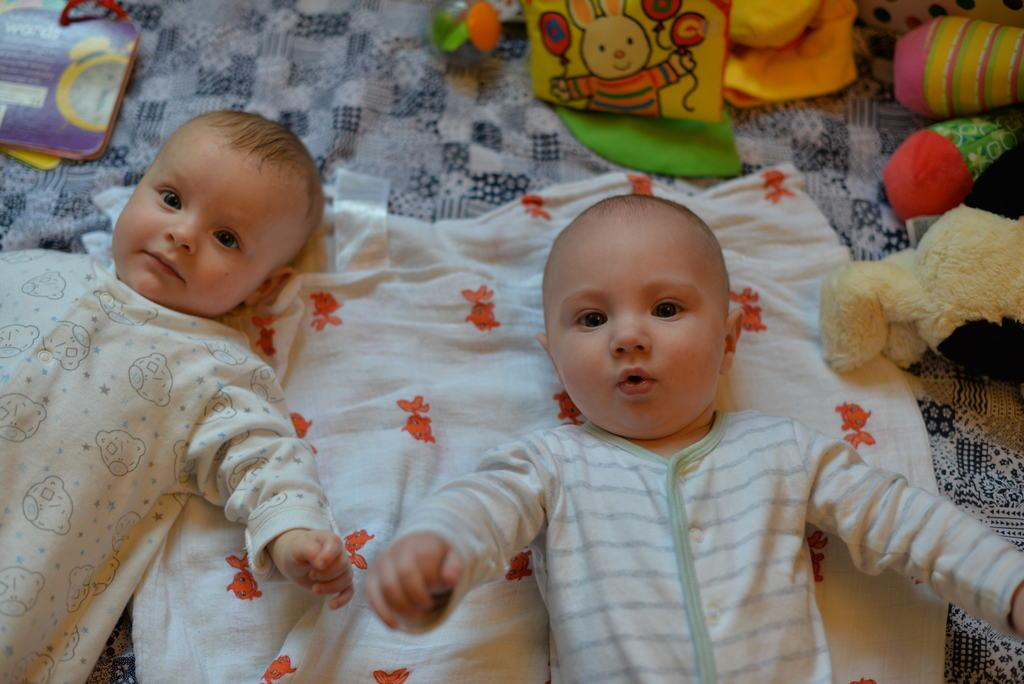What is the main subject of the image? The main subject of the image is two babies sleeping on the bed. What can be seen on the bed besides the babies? There is a white and orange color towel and colorful objects on the bed. What reason does the tramp give for helping the babies in the image? There is no tramp present in the image, and therefore no reason can be given for helping the babies. 